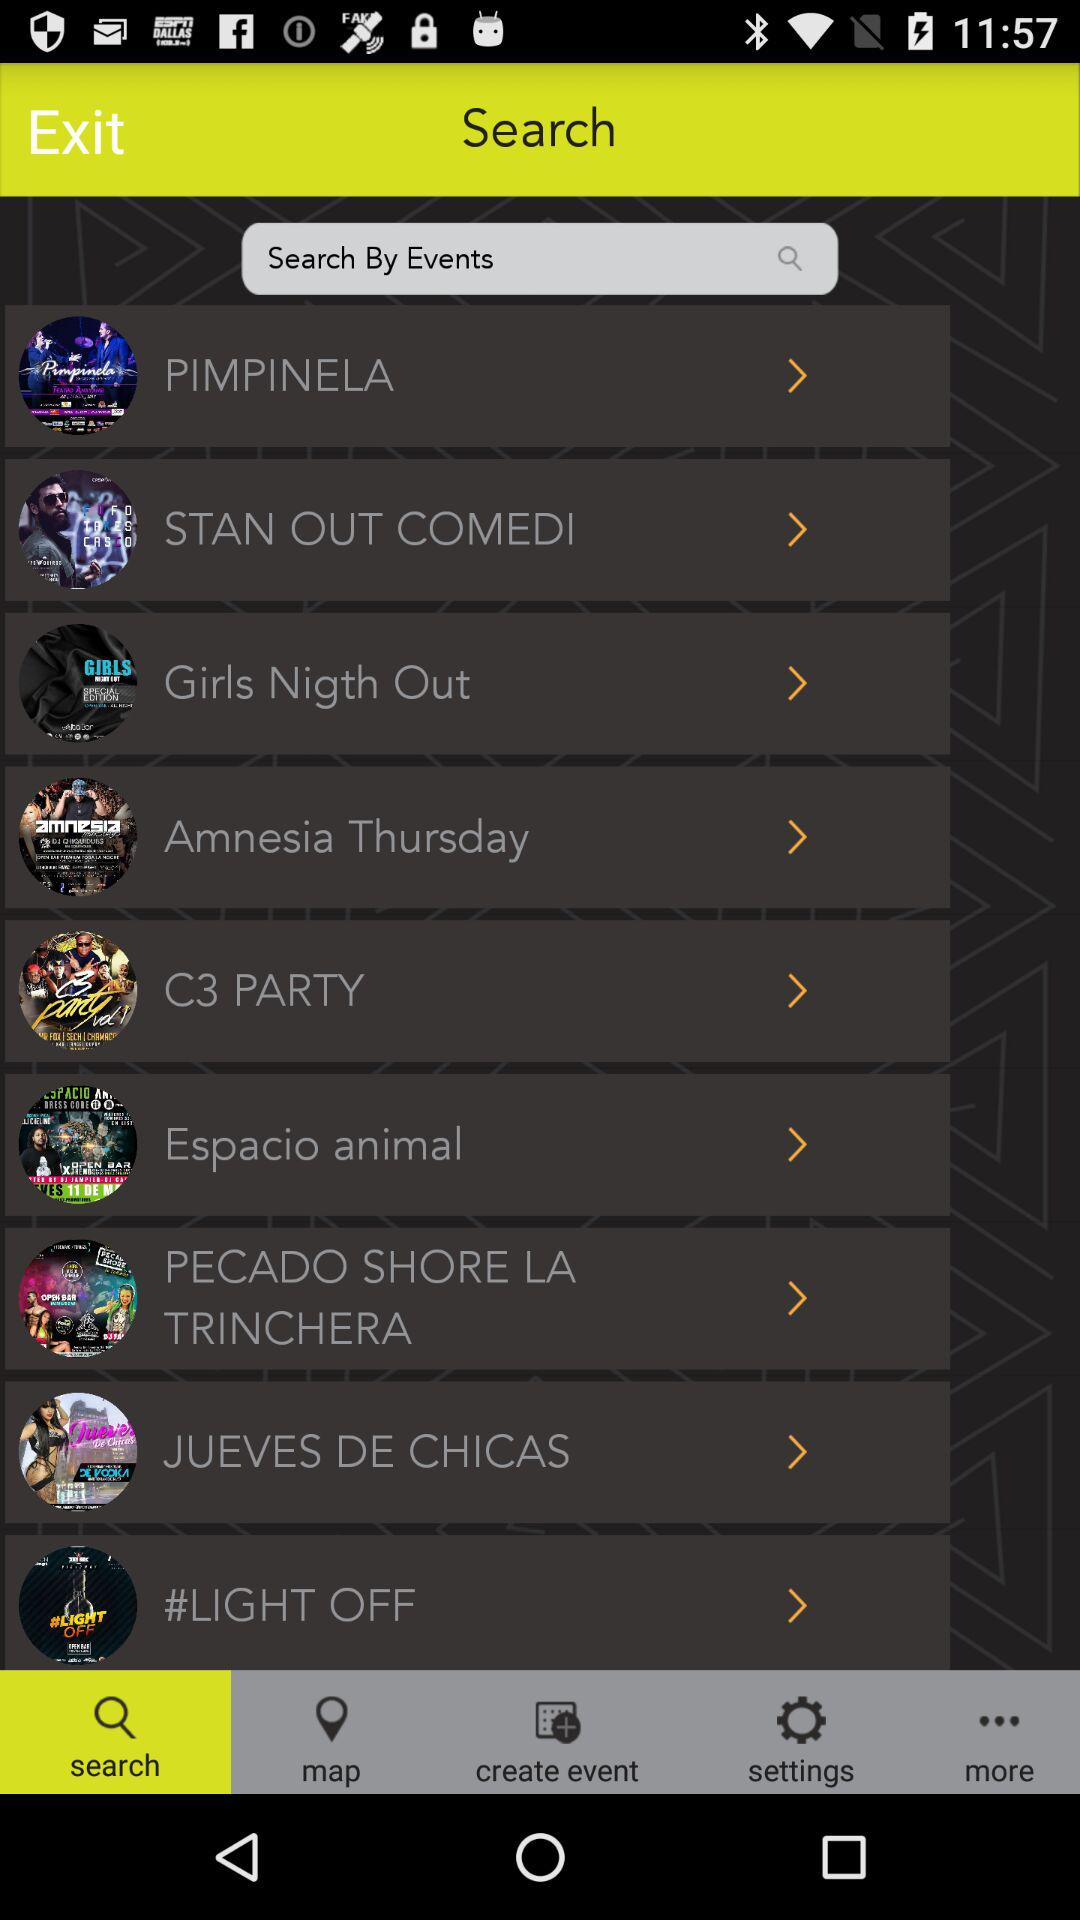Which tab am I using? You are using the "search" tab. 